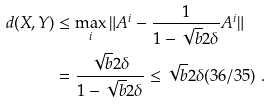Convert formula to latex. <formula><loc_0><loc_0><loc_500><loc_500>d ( X , Y ) & \leq \max _ { i } \| A ^ { i } - \frac { 1 } { 1 - \sqrt { b } 2 \delta } A ^ { i } \| \\ & = \frac { \sqrt { b } 2 \delta } { 1 - \sqrt { b } 2 \delta } \leq \sqrt { b } 2 \delta ( 3 6 / 3 5 ) \ .</formula> 